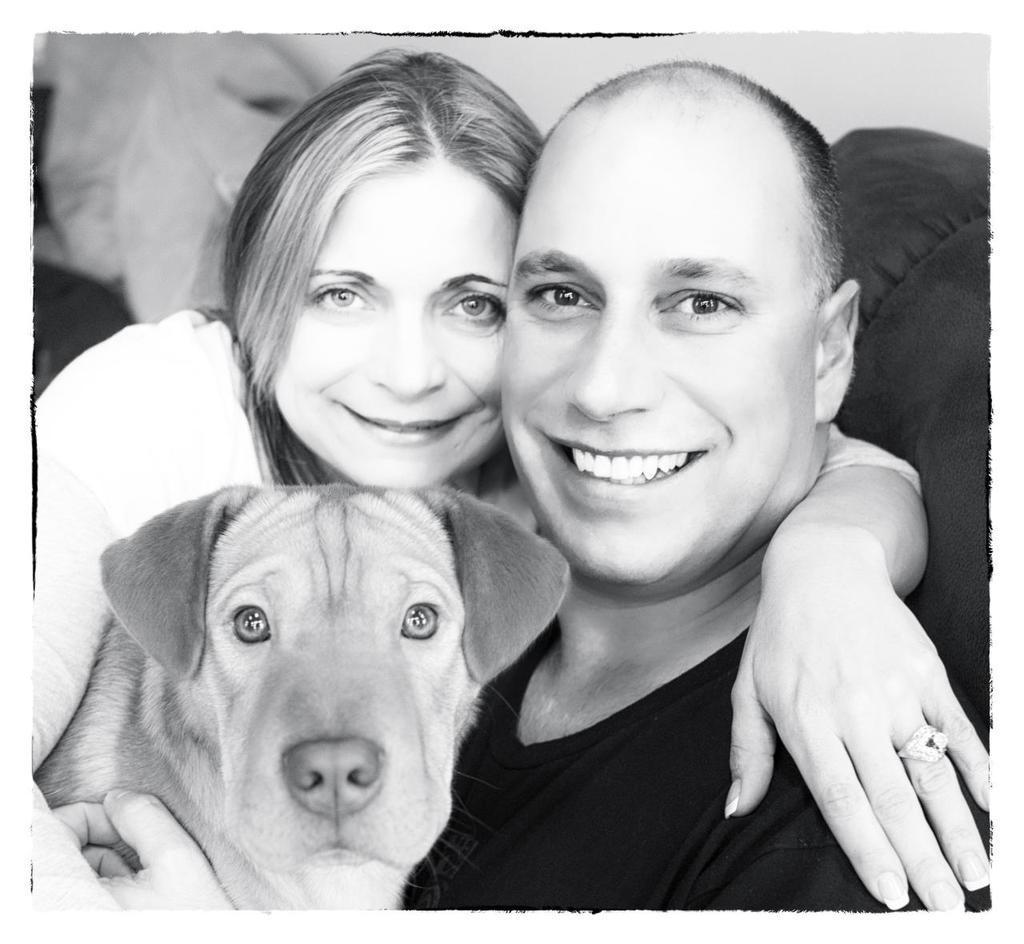Could you give a brief overview of what you see in this image? This is a black and white picture. In this picture we can see a man and a women and a dog. We can see man and woman carrying a beautiful smile on their faces. We can see ring to a woman's finger. 